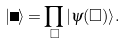<formula> <loc_0><loc_0><loc_500><loc_500>| \Psi \rangle = \prod _ { \Box } | \psi ( \Box ) \rangle .</formula> 